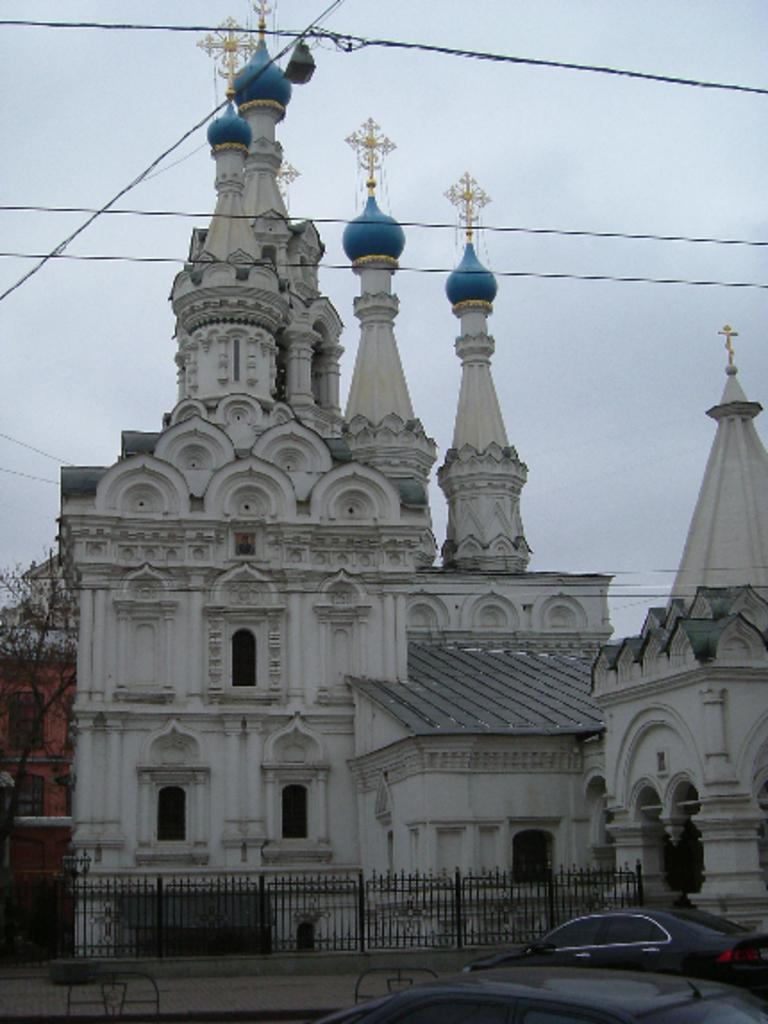Could you give a brief overview of what you see in this image? This image consists of a building. It looks like a temple. At the bottom, we can see the cars. In the front, there is a fence. At the top, there is sky. 